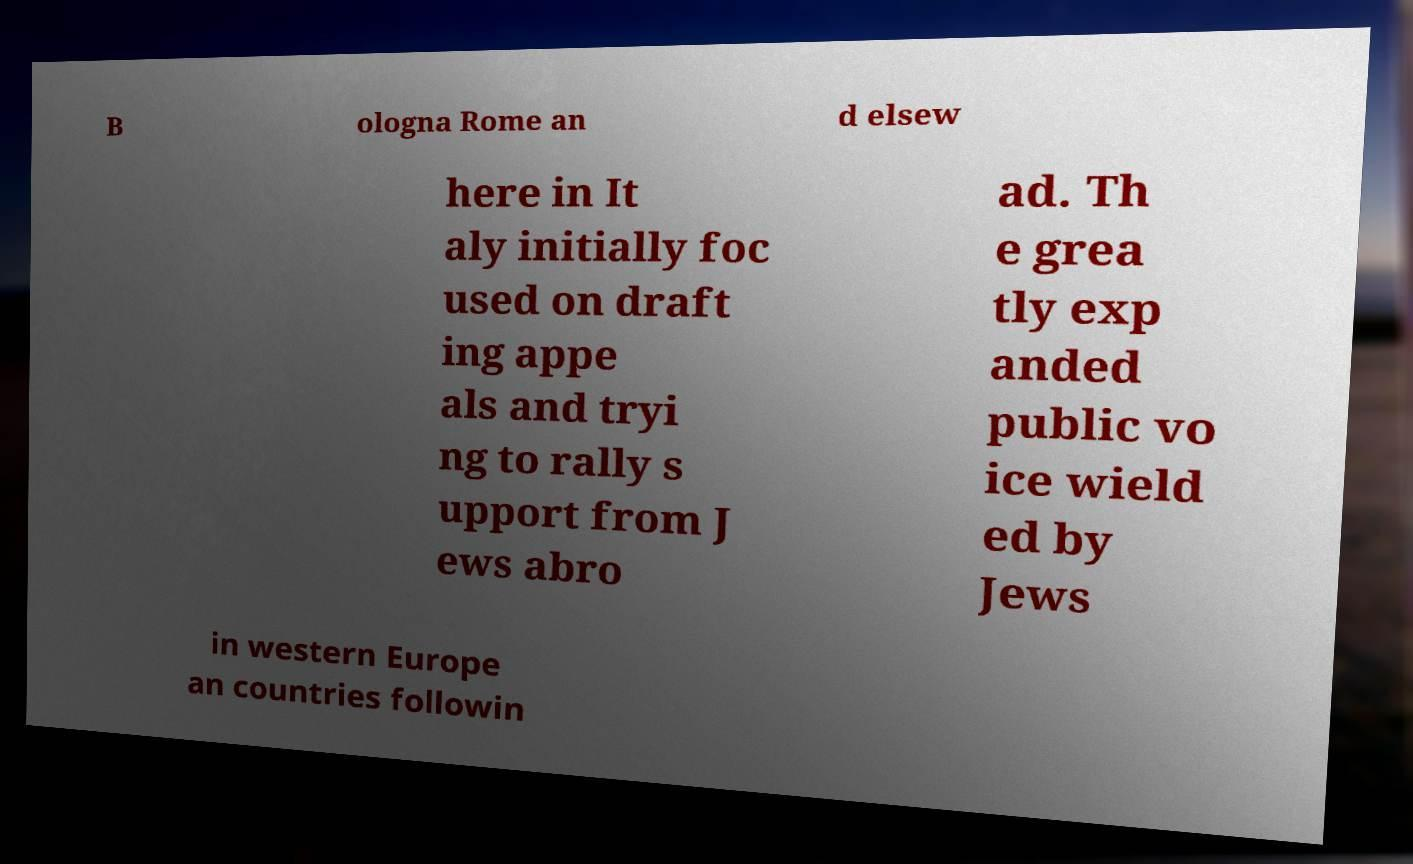Could you assist in decoding the text presented in this image and type it out clearly? B ologna Rome an d elsew here in It aly initially foc used on draft ing appe als and tryi ng to rally s upport from J ews abro ad. Th e grea tly exp anded public vo ice wield ed by Jews in western Europe an countries followin 